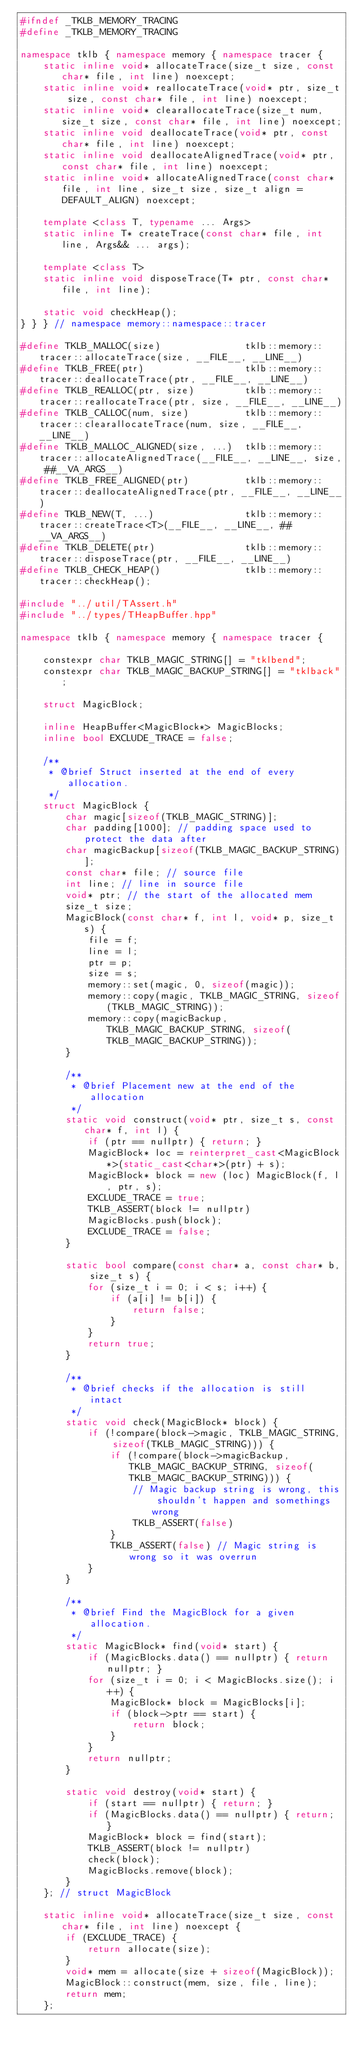<code> <loc_0><loc_0><loc_500><loc_500><_C++_>#ifndef _TKLB_MEMORY_TRACING
#define _TKLB_MEMORY_TRACING

namespace tklb { namespace memory { namespace tracer {
	static inline void* allocateTrace(size_t size, const char* file, int line) noexcept;
	static inline void* reallocateTrace(void* ptr, size_t size, const char* file, int line) noexcept;
	static inline void* clearallocateTrace(size_t num, size_t size, const char* file, int line) noexcept;
	static inline void deallocateTrace(void* ptr, const char* file, int line) noexcept;
	static inline void deallocateAlignedTrace(void* ptr, const char* file, int line) noexcept;
	static inline void* allocateAlignedTrace(const char* file, int line, size_t size, size_t align = DEFAULT_ALIGN) noexcept;

	template <class T, typename ... Args>
	static inline T* createTrace(const char* file, int line, Args&& ... args);

	template <class T>
	static inline void disposeTrace(T* ptr, const char* file, int line);

	static void checkHeap();
} } } // namespace memory::namespace::tracer

#define TKLB_MALLOC(size)				tklb::memory::tracer::allocateTrace(size, __FILE__, __LINE__)
#define TKLB_FREE(ptr)					tklb::memory::tracer::deallocateTrace(ptr, __FILE__, __LINE__)
#define TKLB_REALLOC(ptr, size) 		tklb::memory::tracer::reallocateTrace(ptr, size, __FILE__, __LINE__)
#define TKLB_CALLOC(num, size) 			tklb::memory::tracer::clearallocateTrace(num, size, __FILE__, __LINE__)
#define TKLB_MALLOC_ALIGNED(size, ...)	tklb::memory::tracer::allocateAlignedTrace(__FILE__, __LINE__, size, ##__VA_ARGS__)
#define TKLB_FREE_ALIGNED(ptr)			tklb::memory::tracer::deallocateAlignedTrace(ptr, __FILE__, __LINE__)
#define TKLB_NEW(T, ...)				tklb::memory::tracer::createTrace<T>(__FILE__, __LINE__, ##__VA_ARGS__)
#define TKLB_DELETE(ptr)				tklb::memory::tracer::disposeTrace(ptr, __FILE__, __LINE__)
#define TKLB_CHECK_HEAP()				tklb::memory::tracer::checkHeap();

#include "../util/TAssert.h"
#include "../types/THeapBuffer.hpp"

namespace tklb { namespace memory { namespace tracer {

	constexpr char TKLB_MAGIC_STRING[] = "tklbend";
	constexpr char TKLB_MAGIC_BACKUP_STRING[] = "tklback";

	struct MagicBlock;

	inline HeapBuffer<MagicBlock*> MagicBlocks;
	inline bool EXCLUDE_TRACE = false;

	/**
	 * @brief Struct inserted at the end of every allocation.
	 */
	struct MagicBlock {
		char magic[sizeof(TKLB_MAGIC_STRING)];
		char padding[1000]; // padding space used to protect the data after
		char magicBackup[sizeof(TKLB_MAGIC_BACKUP_STRING)];
		const char* file; // source file
		int line; // line in source file
		void* ptr; // the start of the allocated mem
		size_t size;
		MagicBlock(const char* f, int l, void* p, size_t s) {
			file = f;
			line = l;
			ptr = p;
			size = s;
			memory::set(magic, 0, sizeof(magic));
			memory::copy(magic, TKLB_MAGIC_STRING, sizeof(TKLB_MAGIC_STRING));
			memory::copy(magicBackup, TKLB_MAGIC_BACKUP_STRING, sizeof(TKLB_MAGIC_BACKUP_STRING));
		}

		/**
		 * @brief Placement new at the end of the allocation
		 */
		static void construct(void* ptr, size_t s, const char* f, int l) {
			if (ptr == nullptr) { return; }
			MagicBlock* loc = reinterpret_cast<MagicBlock*>(static_cast<char*>(ptr) + s);
			MagicBlock* block = new (loc) MagicBlock(f, l, ptr, s);
			EXCLUDE_TRACE = true;
			TKLB_ASSERT(block != nullptr)
			MagicBlocks.push(block);
			EXCLUDE_TRACE = false;
		}

		static bool compare(const char* a, const char* b, size_t s) {
			for (size_t i = 0; i < s; i++) {
				if (a[i] != b[i]) {
					return false;
				}
			}
			return true;
		}

		/**
		 * @brief checks if the allocation is still intact
		 */
		static void check(MagicBlock* block) {
			if (!compare(block->magic, TKLB_MAGIC_STRING, sizeof(TKLB_MAGIC_STRING))) {
				if (!compare(block->magicBackup, TKLB_MAGIC_BACKUP_STRING, sizeof(TKLB_MAGIC_BACKUP_STRING))) {
					// Magic backup string is wrong, this shouldn't happen and somethings wrong
					TKLB_ASSERT(false)
				}
				TKLB_ASSERT(false) // Magic string is wrong so it was overrun
			}
		}

		/**
		 * @brief Find the MagicBlock for a given allocation.
		 */
		static MagicBlock* find(void* start) {
			if (MagicBlocks.data() == nullptr) { return nullptr; }
			for (size_t i = 0; i < MagicBlocks.size(); i++) {
				MagicBlock* block = MagicBlocks[i];
				if (block->ptr == start) {
					return block;
				}
			}
			return nullptr;
		}

		static void destroy(void* start) {
			if (start == nullptr) { return; }
			if (MagicBlocks.data() == nullptr) { return; }
			MagicBlock* block = find(start);
			TKLB_ASSERT(block != nullptr)
			check(block);
			MagicBlocks.remove(block);
		}
	}; // struct MagicBlock

	static inline void* allocateTrace(size_t size, const char* file, int line) noexcept {
		if (EXCLUDE_TRACE) {
			return allocate(size);
		}
		void* mem = allocate(size + sizeof(MagicBlock));
		MagicBlock::construct(mem, size, file, line);
		return mem;
	};
</code> 